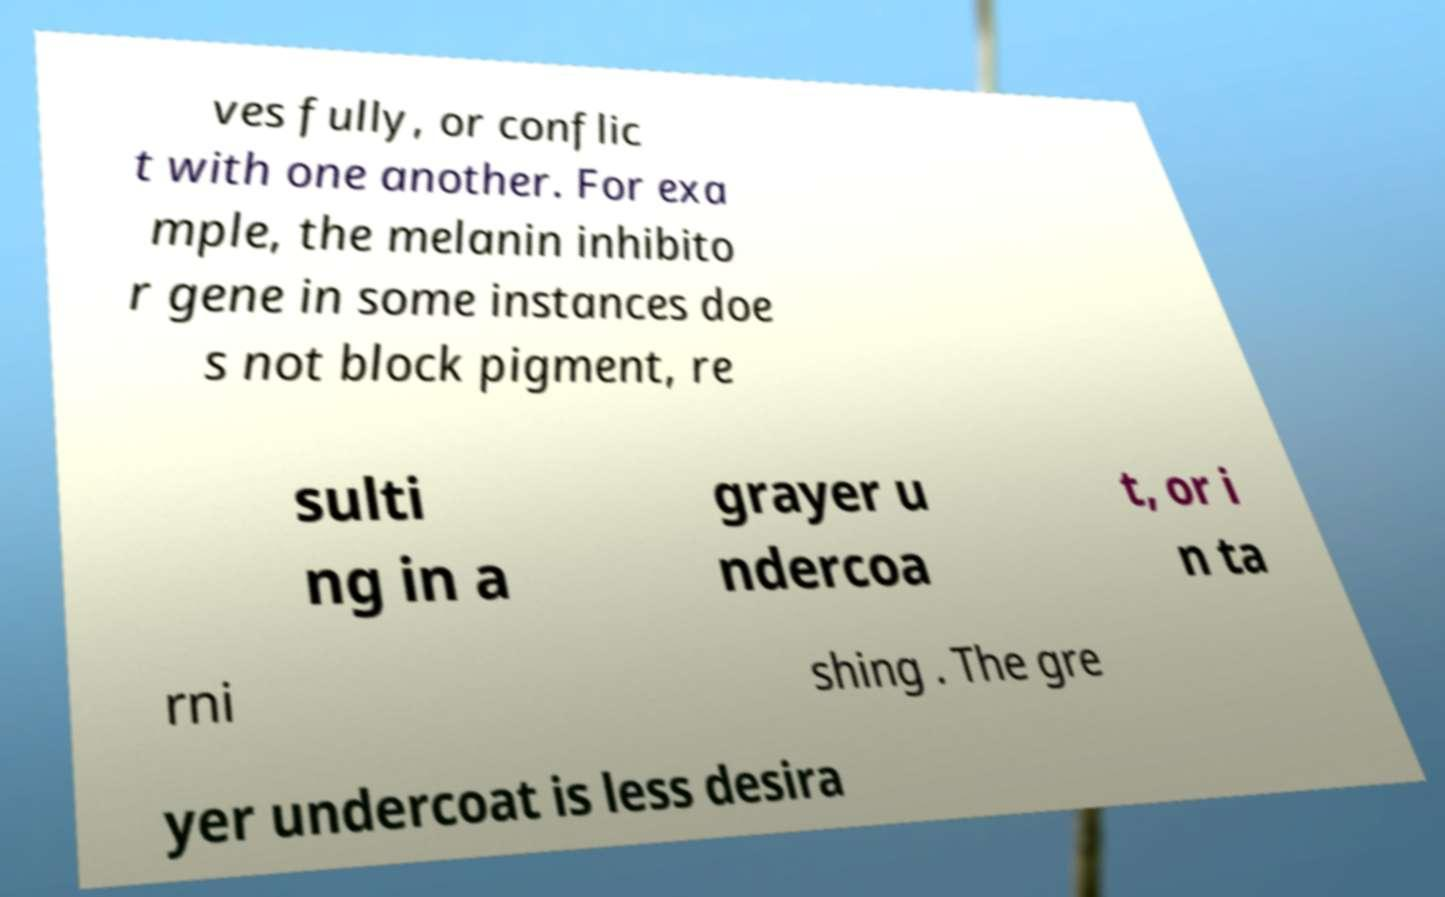Can you accurately transcribe the text from the provided image for me? ves fully, or conflic t with one another. For exa mple, the melanin inhibito r gene in some instances doe s not block pigment, re sulti ng in a grayer u ndercoa t, or i n ta rni shing . The gre yer undercoat is less desira 